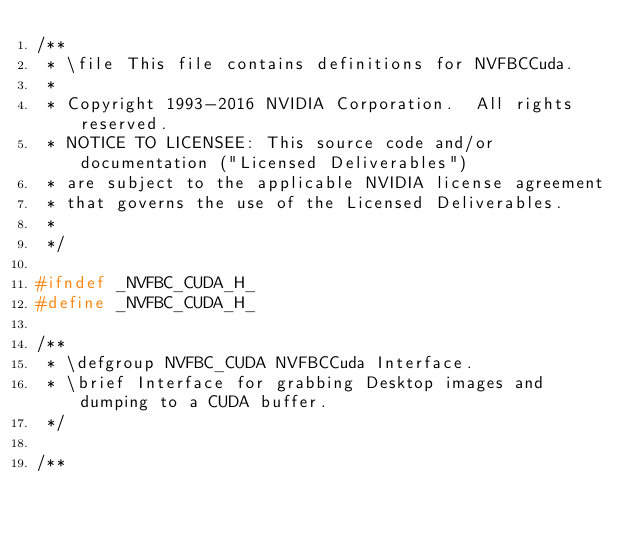Convert code to text. <code><loc_0><loc_0><loc_500><loc_500><_C_>/**
 * \file This file contains definitions for NVFBCCuda.
 *
 * Copyright 1993-2016 NVIDIA Corporation.  All rights reserved.
 * NOTICE TO LICENSEE: This source code and/or documentation ("Licensed Deliverables")
 * are subject to the applicable NVIDIA license agreement
 * that governs the use of the Licensed Deliverables.
 *
 */

#ifndef _NVFBC_CUDA_H_
#define _NVFBC_CUDA_H_

/**
 * \defgroup NVFBC_CUDA NVFBCCuda Interface.
 * \brief Interface for grabbing Desktop images and dumping to a CUDA buffer.
 */

/**</code> 